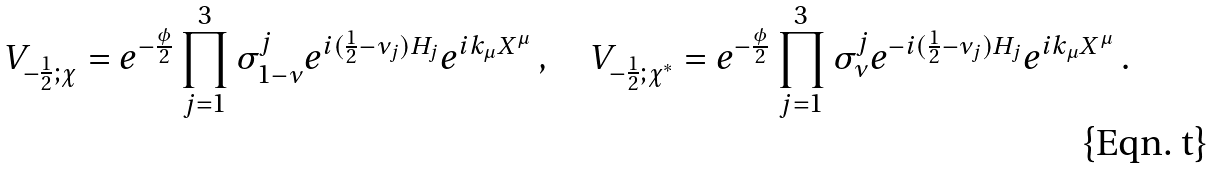Convert formula to latex. <formula><loc_0><loc_0><loc_500><loc_500>V _ { - \frac { 1 } { 2 } ; \chi } = e ^ { - \frac { \phi } { 2 } } \prod _ { j = 1 } ^ { 3 } \sigma _ { 1 - \nu } ^ { j } e ^ { i ( \frac { 1 } { 2 } - \nu _ { j } ) H _ { j } } e ^ { i k _ { \mu } X ^ { \mu } } \, , \quad V _ { - \frac { 1 } { 2 } ; \chi ^ { * } } = e ^ { - \frac { \phi } { 2 } } \prod _ { j = 1 } ^ { 3 } \sigma _ { \nu } ^ { j } e ^ { - i ( \frac { 1 } { 2 } - \nu _ { j } ) H _ { j } } e ^ { i k _ { \mu } X ^ { \mu } } \, .</formula> 